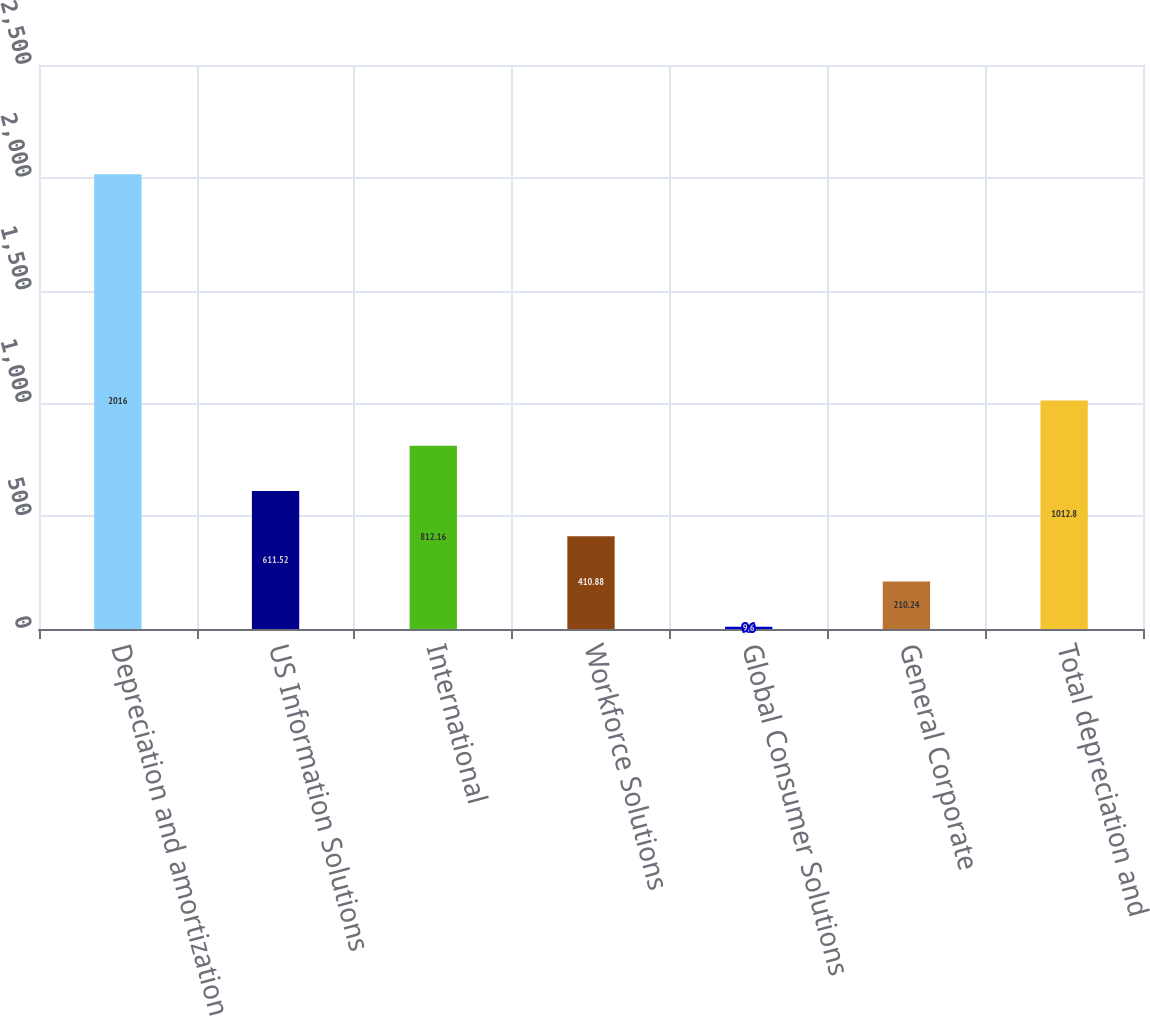Convert chart to OTSL. <chart><loc_0><loc_0><loc_500><loc_500><bar_chart><fcel>Depreciation and amortization<fcel>US Information Solutions<fcel>International<fcel>Workforce Solutions<fcel>Global Consumer Solutions<fcel>General Corporate<fcel>Total depreciation and<nl><fcel>2016<fcel>611.52<fcel>812.16<fcel>410.88<fcel>9.6<fcel>210.24<fcel>1012.8<nl></chart> 